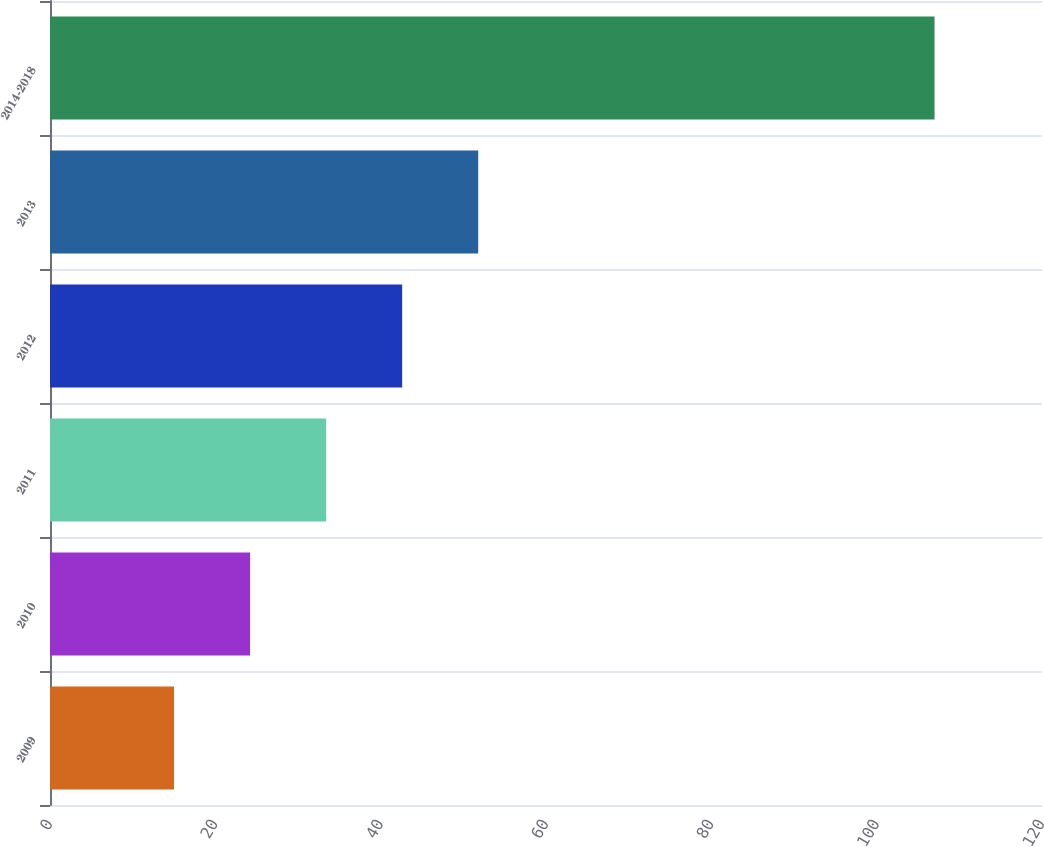Convert chart. <chart><loc_0><loc_0><loc_500><loc_500><bar_chart><fcel>2009<fcel>2010<fcel>2011<fcel>2012<fcel>2013<fcel>2014-2018<nl><fcel>15<fcel>24.2<fcel>33.4<fcel>42.6<fcel>51.8<fcel>107<nl></chart> 